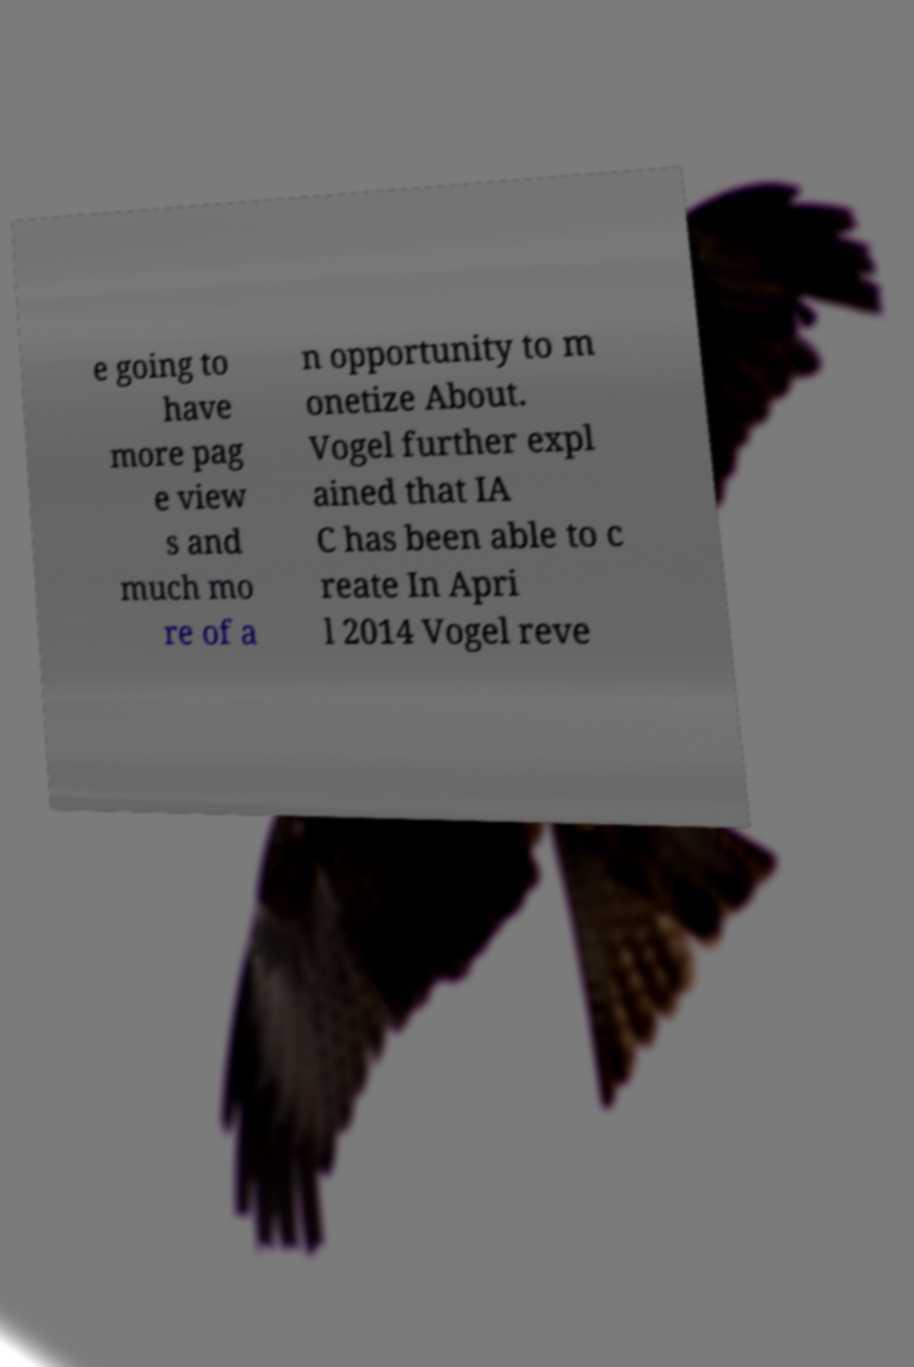Could you assist in decoding the text presented in this image and type it out clearly? e going to have more pag e view s and much mo re of a n opportunity to m onetize About. Vogel further expl ained that IA C has been able to c reate In Apri l 2014 Vogel reve 